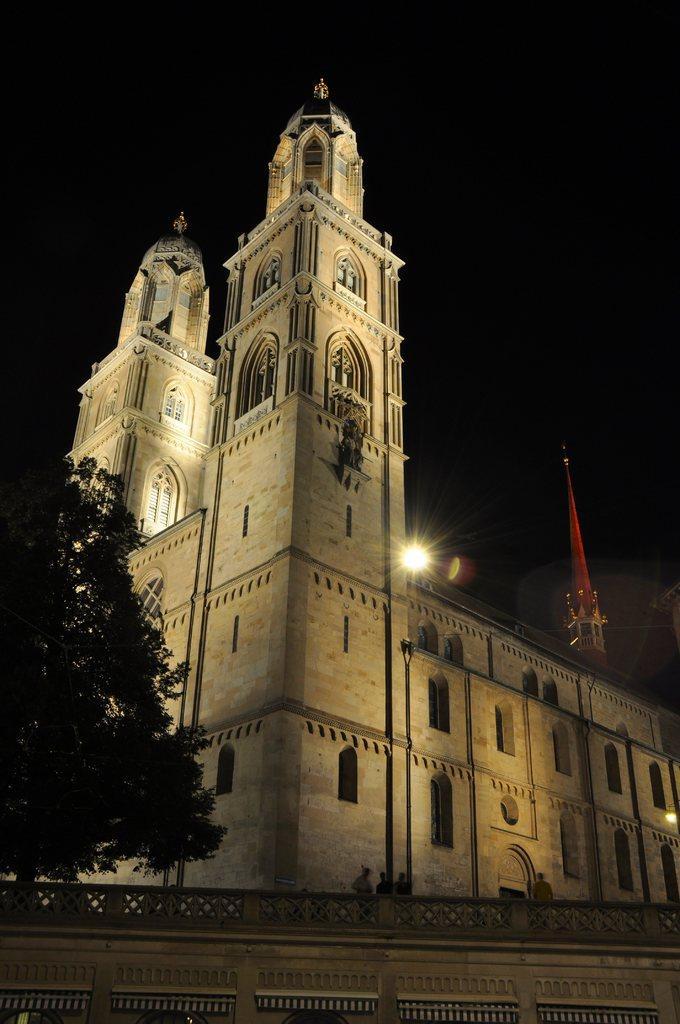Can you describe this image briefly? In this image, I can see a building with the windows. This looks like a light. On the left side of the image, I can see a tree. At the bottom of the image, I can see three people standing. The background looks dark. 